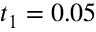<formula> <loc_0><loc_0><loc_500><loc_500>t _ { 1 } = 0 . 0 5</formula> 